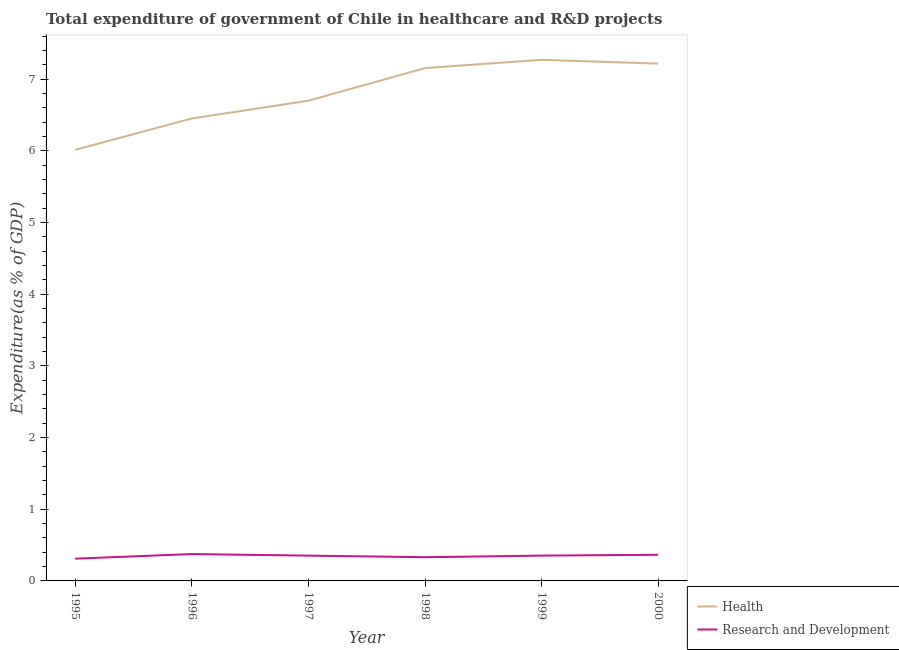How many different coloured lines are there?
Offer a very short reply. 2. What is the expenditure in healthcare in 1997?
Your response must be concise. 6.7. Across all years, what is the maximum expenditure in r&d?
Provide a succinct answer. 0.37. Across all years, what is the minimum expenditure in r&d?
Ensure brevity in your answer.  0.31. In which year was the expenditure in healthcare maximum?
Your answer should be very brief. 1999. In which year was the expenditure in healthcare minimum?
Provide a short and direct response. 1995. What is the total expenditure in healthcare in the graph?
Offer a very short reply. 40.81. What is the difference between the expenditure in healthcare in 1995 and that in 1996?
Your answer should be compact. -0.44. What is the difference between the expenditure in healthcare in 1996 and the expenditure in r&d in 1997?
Keep it short and to the point. 6.1. What is the average expenditure in healthcare per year?
Your response must be concise. 6.8. In the year 2000, what is the difference between the expenditure in healthcare and expenditure in r&d?
Your answer should be very brief. 6.85. What is the ratio of the expenditure in healthcare in 1997 to that in 1998?
Your answer should be very brief. 0.94. Is the expenditure in r&d in 1995 less than that in 1997?
Offer a terse response. Yes. What is the difference between the highest and the second highest expenditure in r&d?
Make the answer very short. 0.01. What is the difference between the highest and the lowest expenditure in healthcare?
Ensure brevity in your answer.  1.26. Does the expenditure in healthcare monotonically increase over the years?
Make the answer very short. No. Is the expenditure in r&d strictly greater than the expenditure in healthcare over the years?
Your answer should be compact. No. Is the expenditure in healthcare strictly less than the expenditure in r&d over the years?
Keep it short and to the point. No. What is the title of the graph?
Your answer should be very brief. Total expenditure of government of Chile in healthcare and R&D projects. What is the label or title of the X-axis?
Your answer should be compact. Year. What is the label or title of the Y-axis?
Your response must be concise. Expenditure(as % of GDP). What is the Expenditure(as % of GDP) of Health in 1995?
Provide a succinct answer. 6.01. What is the Expenditure(as % of GDP) of Research and Development in 1995?
Keep it short and to the point. 0.31. What is the Expenditure(as % of GDP) in Health in 1996?
Your answer should be very brief. 6.45. What is the Expenditure(as % of GDP) in Research and Development in 1996?
Keep it short and to the point. 0.37. What is the Expenditure(as % of GDP) in Health in 1997?
Keep it short and to the point. 6.7. What is the Expenditure(as % of GDP) in Research and Development in 1997?
Provide a short and direct response. 0.35. What is the Expenditure(as % of GDP) in Health in 1998?
Ensure brevity in your answer.  7.16. What is the Expenditure(as % of GDP) of Research and Development in 1998?
Provide a short and direct response. 0.33. What is the Expenditure(as % of GDP) in Health in 1999?
Make the answer very short. 7.27. What is the Expenditure(as % of GDP) of Research and Development in 1999?
Give a very brief answer. 0.35. What is the Expenditure(as % of GDP) of Health in 2000?
Ensure brevity in your answer.  7.22. What is the Expenditure(as % of GDP) in Research and Development in 2000?
Provide a succinct answer. 0.36. Across all years, what is the maximum Expenditure(as % of GDP) of Health?
Offer a very short reply. 7.27. Across all years, what is the maximum Expenditure(as % of GDP) in Research and Development?
Your response must be concise. 0.37. Across all years, what is the minimum Expenditure(as % of GDP) in Health?
Provide a short and direct response. 6.01. Across all years, what is the minimum Expenditure(as % of GDP) in Research and Development?
Ensure brevity in your answer.  0.31. What is the total Expenditure(as % of GDP) in Health in the graph?
Make the answer very short. 40.81. What is the total Expenditure(as % of GDP) of Research and Development in the graph?
Provide a succinct answer. 2.09. What is the difference between the Expenditure(as % of GDP) of Health in 1995 and that in 1996?
Your answer should be compact. -0.44. What is the difference between the Expenditure(as % of GDP) in Research and Development in 1995 and that in 1996?
Your answer should be very brief. -0.06. What is the difference between the Expenditure(as % of GDP) of Health in 1995 and that in 1997?
Make the answer very short. -0.69. What is the difference between the Expenditure(as % of GDP) of Research and Development in 1995 and that in 1997?
Your answer should be compact. -0.04. What is the difference between the Expenditure(as % of GDP) in Health in 1995 and that in 1998?
Offer a terse response. -1.14. What is the difference between the Expenditure(as % of GDP) of Research and Development in 1995 and that in 1998?
Give a very brief answer. -0.02. What is the difference between the Expenditure(as % of GDP) of Health in 1995 and that in 1999?
Keep it short and to the point. -1.26. What is the difference between the Expenditure(as % of GDP) in Research and Development in 1995 and that in 1999?
Offer a terse response. -0.04. What is the difference between the Expenditure(as % of GDP) in Health in 1995 and that in 2000?
Ensure brevity in your answer.  -1.2. What is the difference between the Expenditure(as % of GDP) of Research and Development in 1995 and that in 2000?
Provide a succinct answer. -0.05. What is the difference between the Expenditure(as % of GDP) in Health in 1996 and that in 1997?
Your response must be concise. -0.25. What is the difference between the Expenditure(as % of GDP) of Research and Development in 1996 and that in 1997?
Your response must be concise. 0.02. What is the difference between the Expenditure(as % of GDP) of Health in 1996 and that in 1998?
Provide a short and direct response. -0.7. What is the difference between the Expenditure(as % of GDP) in Research and Development in 1996 and that in 1998?
Your response must be concise. 0.04. What is the difference between the Expenditure(as % of GDP) of Health in 1996 and that in 1999?
Offer a terse response. -0.82. What is the difference between the Expenditure(as % of GDP) in Research and Development in 1996 and that in 1999?
Your response must be concise. 0.02. What is the difference between the Expenditure(as % of GDP) of Health in 1996 and that in 2000?
Ensure brevity in your answer.  -0.77. What is the difference between the Expenditure(as % of GDP) in Research and Development in 1996 and that in 2000?
Keep it short and to the point. 0.01. What is the difference between the Expenditure(as % of GDP) of Health in 1997 and that in 1998?
Offer a terse response. -0.46. What is the difference between the Expenditure(as % of GDP) in Research and Development in 1997 and that in 1998?
Your answer should be very brief. 0.02. What is the difference between the Expenditure(as % of GDP) in Health in 1997 and that in 1999?
Offer a very short reply. -0.57. What is the difference between the Expenditure(as % of GDP) in Research and Development in 1997 and that in 1999?
Provide a short and direct response. -0. What is the difference between the Expenditure(as % of GDP) in Health in 1997 and that in 2000?
Offer a very short reply. -0.52. What is the difference between the Expenditure(as % of GDP) in Research and Development in 1997 and that in 2000?
Your answer should be compact. -0.01. What is the difference between the Expenditure(as % of GDP) of Health in 1998 and that in 1999?
Keep it short and to the point. -0.12. What is the difference between the Expenditure(as % of GDP) of Research and Development in 1998 and that in 1999?
Offer a very short reply. -0.02. What is the difference between the Expenditure(as % of GDP) in Health in 1998 and that in 2000?
Provide a succinct answer. -0.06. What is the difference between the Expenditure(as % of GDP) in Research and Development in 1998 and that in 2000?
Ensure brevity in your answer.  -0.03. What is the difference between the Expenditure(as % of GDP) of Health in 1999 and that in 2000?
Keep it short and to the point. 0.05. What is the difference between the Expenditure(as % of GDP) in Research and Development in 1999 and that in 2000?
Provide a short and direct response. -0.01. What is the difference between the Expenditure(as % of GDP) in Health in 1995 and the Expenditure(as % of GDP) in Research and Development in 1996?
Offer a terse response. 5.64. What is the difference between the Expenditure(as % of GDP) of Health in 1995 and the Expenditure(as % of GDP) of Research and Development in 1997?
Provide a short and direct response. 5.66. What is the difference between the Expenditure(as % of GDP) of Health in 1995 and the Expenditure(as % of GDP) of Research and Development in 1998?
Give a very brief answer. 5.68. What is the difference between the Expenditure(as % of GDP) of Health in 1995 and the Expenditure(as % of GDP) of Research and Development in 1999?
Provide a short and direct response. 5.66. What is the difference between the Expenditure(as % of GDP) in Health in 1995 and the Expenditure(as % of GDP) in Research and Development in 2000?
Give a very brief answer. 5.65. What is the difference between the Expenditure(as % of GDP) in Health in 1996 and the Expenditure(as % of GDP) in Research and Development in 1997?
Provide a succinct answer. 6.1. What is the difference between the Expenditure(as % of GDP) in Health in 1996 and the Expenditure(as % of GDP) in Research and Development in 1998?
Keep it short and to the point. 6.12. What is the difference between the Expenditure(as % of GDP) of Health in 1996 and the Expenditure(as % of GDP) of Research and Development in 1999?
Ensure brevity in your answer.  6.1. What is the difference between the Expenditure(as % of GDP) of Health in 1996 and the Expenditure(as % of GDP) of Research and Development in 2000?
Give a very brief answer. 6.09. What is the difference between the Expenditure(as % of GDP) in Health in 1997 and the Expenditure(as % of GDP) in Research and Development in 1998?
Your answer should be compact. 6.37. What is the difference between the Expenditure(as % of GDP) in Health in 1997 and the Expenditure(as % of GDP) in Research and Development in 1999?
Your answer should be compact. 6.35. What is the difference between the Expenditure(as % of GDP) in Health in 1997 and the Expenditure(as % of GDP) in Research and Development in 2000?
Provide a succinct answer. 6.33. What is the difference between the Expenditure(as % of GDP) in Health in 1998 and the Expenditure(as % of GDP) in Research and Development in 1999?
Ensure brevity in your answer.  6.8. What is the difference between the Expenditure(as % of GDP) of Health in 1998 and the Expenditure(as % of GDP) of Research and Development in 2000?
Make the answer very short. 6.79. What is the difference between the Expenditure(as % of GDP) in Health in 1999 and the Expenditure(as % of GDP) in Research and Development in 2000?
Ensure brevity in your answer.  6.91. What is the average Expenditure(as % of GDP) in Health per year?
Your response must be concise. 6.8. What is the average Expenditure(as % of GDP) in Research and Development per year?
Your response must be concise. 0.35. In the year 1995, what is the difference between the Expenditure(as % of GDP) of Health and Expenditure(as % of GDP) of Research and Development?
Provide a short and direct response. 5.7. In the year 1996, what is the difference between the Expenditure(as % of GDP) in Health and Expenditure(as % of GDP) in Research and Development?
Give a very brief answer. 6.08. In the year 1997, what is the difference between the Expenditure(as % of GDP) of Health and Expenditure(as % of GDP) of Research and Development?
Offer a very short reply. 6.35. In the year 1998, what is the difference between the Expenditure(as % of GDP) of Health and Expenditure(as % of GDP) of Research and Development?
Give a very brief answer. 6.82. In the year 1999, what is the difference between the Expenditure(as % of GDP) of Health and Expenditure(as % of GDP) of Research and Development?
Your response must be concise. 6.92. In the year 2000, what is the difference between the Expenditure(as % of GDP) of Health and Expenditure(as % of GDP) of Research and Development?
Offer a terse response. 6.85. What is the ratio of the Expenditure(as % of GDP) in Health in 1995 to that in 1996?
Ensure brevity in your answer.  0.93. What is the ratio of the Expenditure(as % of GDP) in Research and Development in 1995 to that in 1996?
Offer a terse response. 0.83. What is the ratio of the Expenditure(as % of GDP) of Health in 1995 to that in 1997?
Your answer should be very brief. 0.9. What is the ratio of the Expenditure(as % of GDP) of Research and Development in 1995 to that in 1997?
Make the answer very short. 0.88. What is the ratio of the Expenditure(as % of GDP) in Health in 1995 to that in 1998?
Offer a very short reply. 0.84. What is the ratio of the Expenditure(as % of GDP) in Research and Development in 1995 to that in 1998?
Your response must be concise. 0.94. What is the ratio of the Expenditure(as % of GDP) of Health in 1995 to that in 1999?
Ensure brevity in your answer.  0.83. What is the ratio of the Expenditure(as % of GDP) of Research and Development in 1995 to that in 1999?
Offer a terse response. 0.88. What is the ratio of the Expenditure(as % of GDP) in Health in 1995 to that in 2000?
Your response must be concise. 0.83. What is the ratio of the Expenditure(as % of GDP) in Research and Development in 1995 to that in 2000?
Ensure brevity in your answer.  0.85. What is the ratio of the Expenditure(as % of GDP) of Health in 1996 to that in 1997?
Provide a succinct answer. 0.96. What is the ratio of the Expenditure(as % of GDP) of Research and Development in 1996 to that in 1997?
Your answer should be compact. 1.06. What is the ratio of the Expenditure(as % of GDP) in Health in 1996 to that in 1998?
Your response must be concise. 0.9. What is the ratio of the Expenditure(as % of GDP) of Research and Development in 1996 to that in 1998?
Offer a terse response. 1.13. What is the ratio of the Expenditure(as % of GDP) of Health in 1996 to that in 1999?
Provide a succinct answer. 0.89. What is the ratio of the Expenditure(as % of GDP) in Research and Development in 1996 to that in 1999?
Your response must be concise. 1.06. What is the ratio of the Expenditure(as % of GDP) of Health in 1996 to that in 2000?
Provide a short and direct response. 0.89. What is the ratio of the Expenditure(as % of GDP) of Research and Development in 1996 to that in 2000?
Provide a succinct answer. 1.03. What is the ratio of the Expenditure(as % of GDP) in Health in 1997 to that in 1998?
Keep it short and to the point. 0.94. What is the ratio of the Expenditure(as % of GDP) in Research and Development in 1997 to that in 1998?
Provide a succinct answer. 1.07. What is the ratio of the Expenditure(as % of GDP) of Health in 1997 to that in 1999?
Offer a very short reply. 0.92. What is the ratio of the Expenditure(as % of GDP) of Health in 1997 to that in 2000?
Your answer should be very brief. 0.93. What is the ratio of the Expenditure(as % of GDP) of Research and Development in 1997 to that in 2000?
Your answer should be very brief. 0.97. What is the ratio of the Expenditure(as % of GDP) in Health in 1998 to that in 1999?
Give a very brief answer. 0.98. What is the ratio of the Expenditure(as % of GDP) of Research and Development in 1998 to that in 1999?
Provide a short and direct response. 0.94. What is the ratio of the Expenditure(as % of GDP) of Research and Development in 1998 to that in 2000?
Your answer should be compact. 0.91. What is the ratio of the Expenditure(as % of GDP) in Health in 1999 to that in 2000?
Give a very brief answer. 1.01. What is the ratio of the Expenditure(as % of GDP) in Research and Development in 1999 to that in 2000?
Ensure brevity in your answer.  0.97. What is the difference between the highest and the second highest Expenditure(as % of GDP) of Health?
Give a very brief answer. 0.05. What is the difference between the highest and the second highest Expenditure(as % of GDP) of Research and Development?
Provide a succinct answer. 0.01. What is the difference between the highest and the lowest Expenditure(as % of GDP) of Health?
Make the answer very short. 1.26. What is the difference between the highest and the lowest Expenditure(as % of GDP) in Research and Development?
Ensure brevity in your answer.  0.06. 